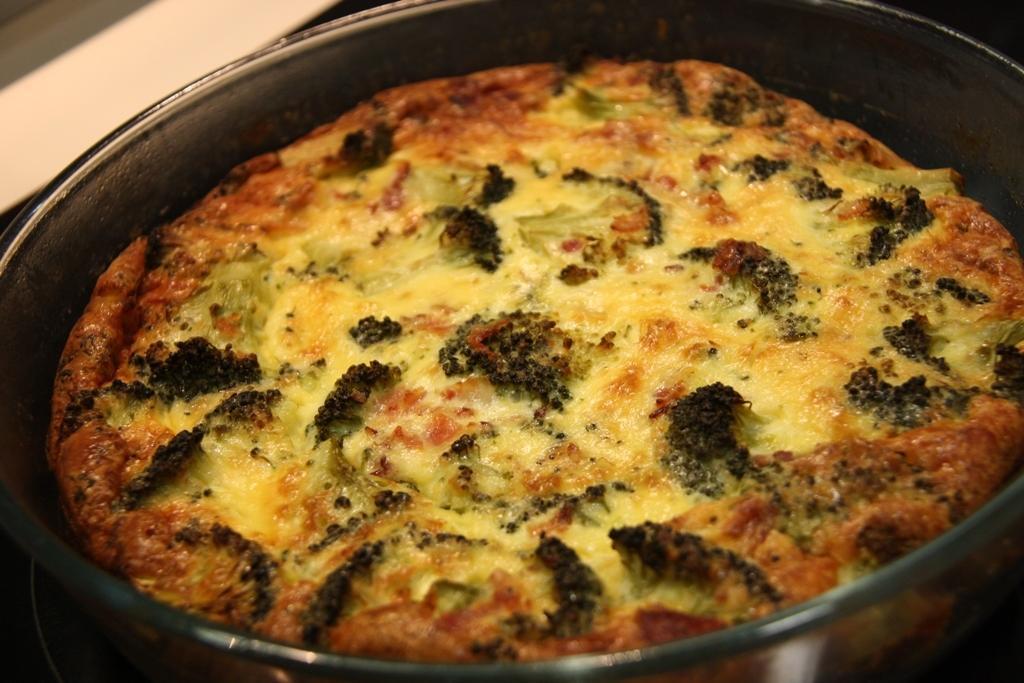Please provide a concise description of this image. We can see bowl with food. 